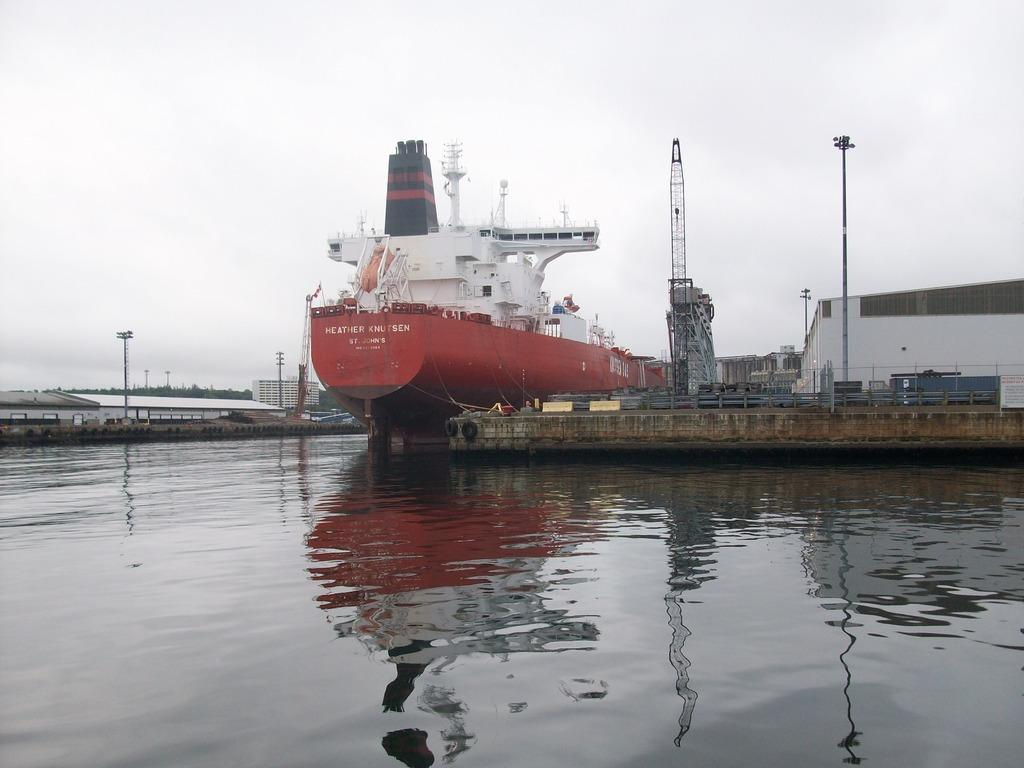<image>
Give a short and clear explanation of the subsequent image. Red ship parked with the words "Heather Knutsen" on the front. 